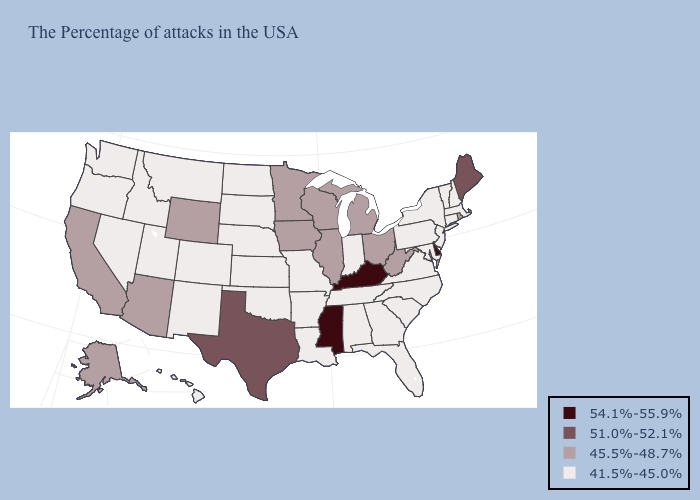Which states have the lowest value in the MidWest?
Concise answer only. Indiana, Missouri, Kansas, Nebraska, South Dakota, North Dakota. Is the legend a continuous bar?
Short answer required. No. Does the map have missing data?
Concise answer only. No. What is the lowest value in states that border Arkansas?
Concise answer only. 41.5%-45.0%. What is the highest value in states that border Kentucky?
Write a very short answer. 45.5%-48.7%. Among the states that border Tennessee , does Mississippi have the highest value?
Give a very brief answer. Yes. Does the map have missing data?
Keep it brief. No. Among the states that border Delaware , which have the lowest value?
Answer briefly. New Jersey, Maryland, Pennsylvania. What is the value of New Mexico?
Concise answer only. 41.5%-45.0%. Is the legend a continuous bar?
Give a very brief answer. No. Does Mississippi have the highest value in the USA?
Write a very short answer. Yes. What is the value of Rhode Island?
Be succinct. 45.5%-48.7%. What is the value of Michigan?
Short answer required. 45.5%-48.7%. What is the value of Indiana?
Give a very brief answer. 41.5%-45.0%. Does New Jersey have a lower value than Oregon?
Be succinct. No. 